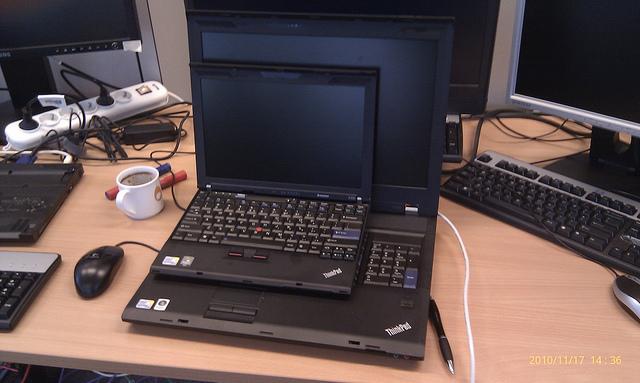Is the computer on?
Be succinct. No. Is the laptop on?
Keep it brief. No. Is this an open laptop computer?
Be succinct. Yes. How is the smaller laptop oriented in relationship to the larger laptop?
Write a very short answer. On top. What is in surge protector?
Give a very brief answer. Plugs. 